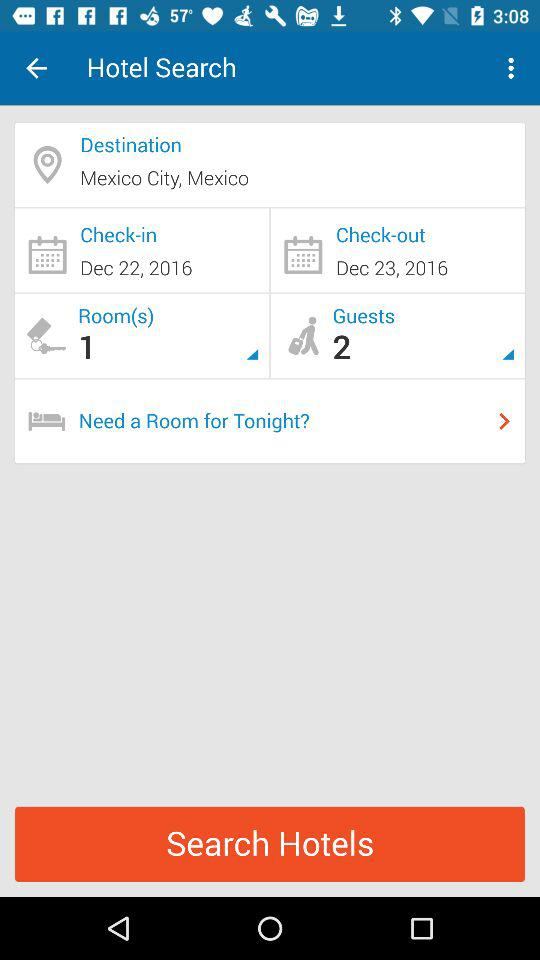What is the check-in date? The check-in date is December 22, 2016. 